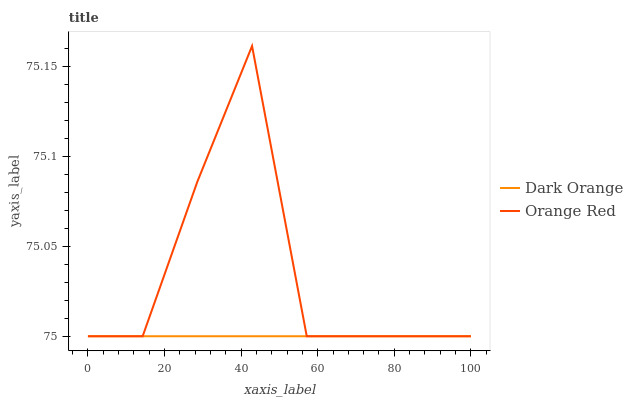Does Dark Orange have the minimum area under the curve?
Answer yes or no. Yes. Does Orange Red have the maximum area under the curve?
Answer yes or no. Yes. Does Orange Red have the minimum area under the curve?
Answer yes or no. No. Is Dark Orange the smoothest?
Answer yes or no. Yes. Is Orange Red the roughest?
Answer yes or no. Yes. Is Orange Red the smoothest?
Answer yes or no. No. Does Dark Orange have the lowest value?
Answer yes or no. Yes. Does Orange Red have the highest value?
Answer yes or no. Yes. Does Orange Red intersect Dark Orange?
Answer yes or no. Yes. Is Orange Red less than Dark Orange?
Answer yes or no. No. Is Orange Red greater than Dark Orange?
Answer yes or no. No. 